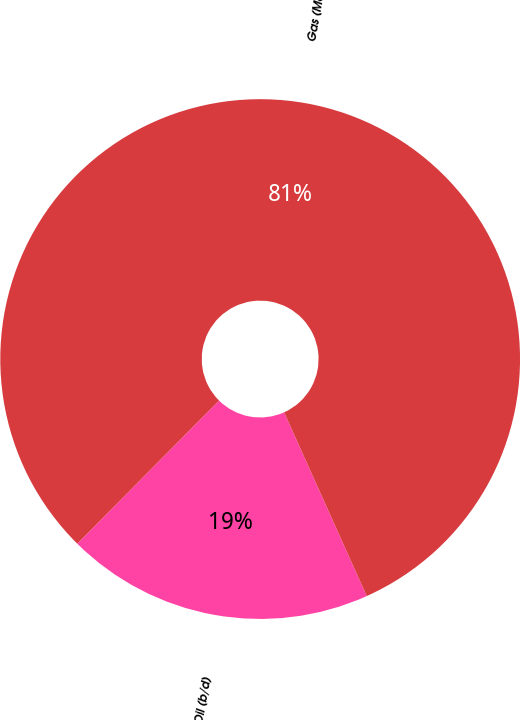Convert chart to OTSL. <chart><loc_0><loc_0><loc_500><loc_500><pie_chart><fcel>Oil (b/d)<fcel>Gas (Mcf/d)<nl><fcel>19.15%<fcel>80.85%<nl></chart> 